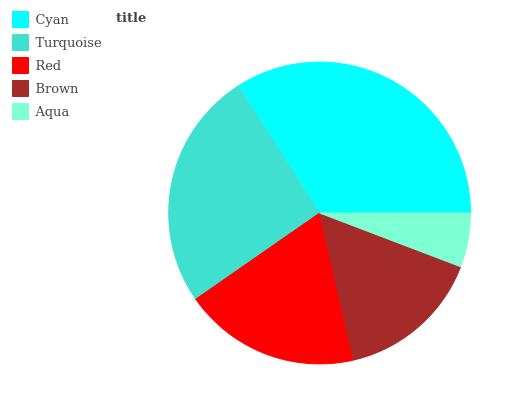Is Aqua the minimum?
Answer yes or no. Yes. Is Cyan the maximum?
Answer yes or no. Yes. Is Turquoise the minimum?
Answer yes or no. No. Is Turquoise the maximum?
Answer yes or no. No. Is Cyan greater than Turquoise?
Answer yes or no. Yes. Is Turquoise less than Cyan?
Answer yes or no. Yes. Is Turquoise greater than Cyan?
Answer yes or no. No. Is Cyan less than Turquoise?
Answer yes or no. No. Is Red the high median?
Answer yes or no. Yes. Is Red the low median?
Answer yes or no. Yes. Is Cyan the high median?
Answer yes or no. No. Is Cyan the low median?
Answer yes or no. No. 